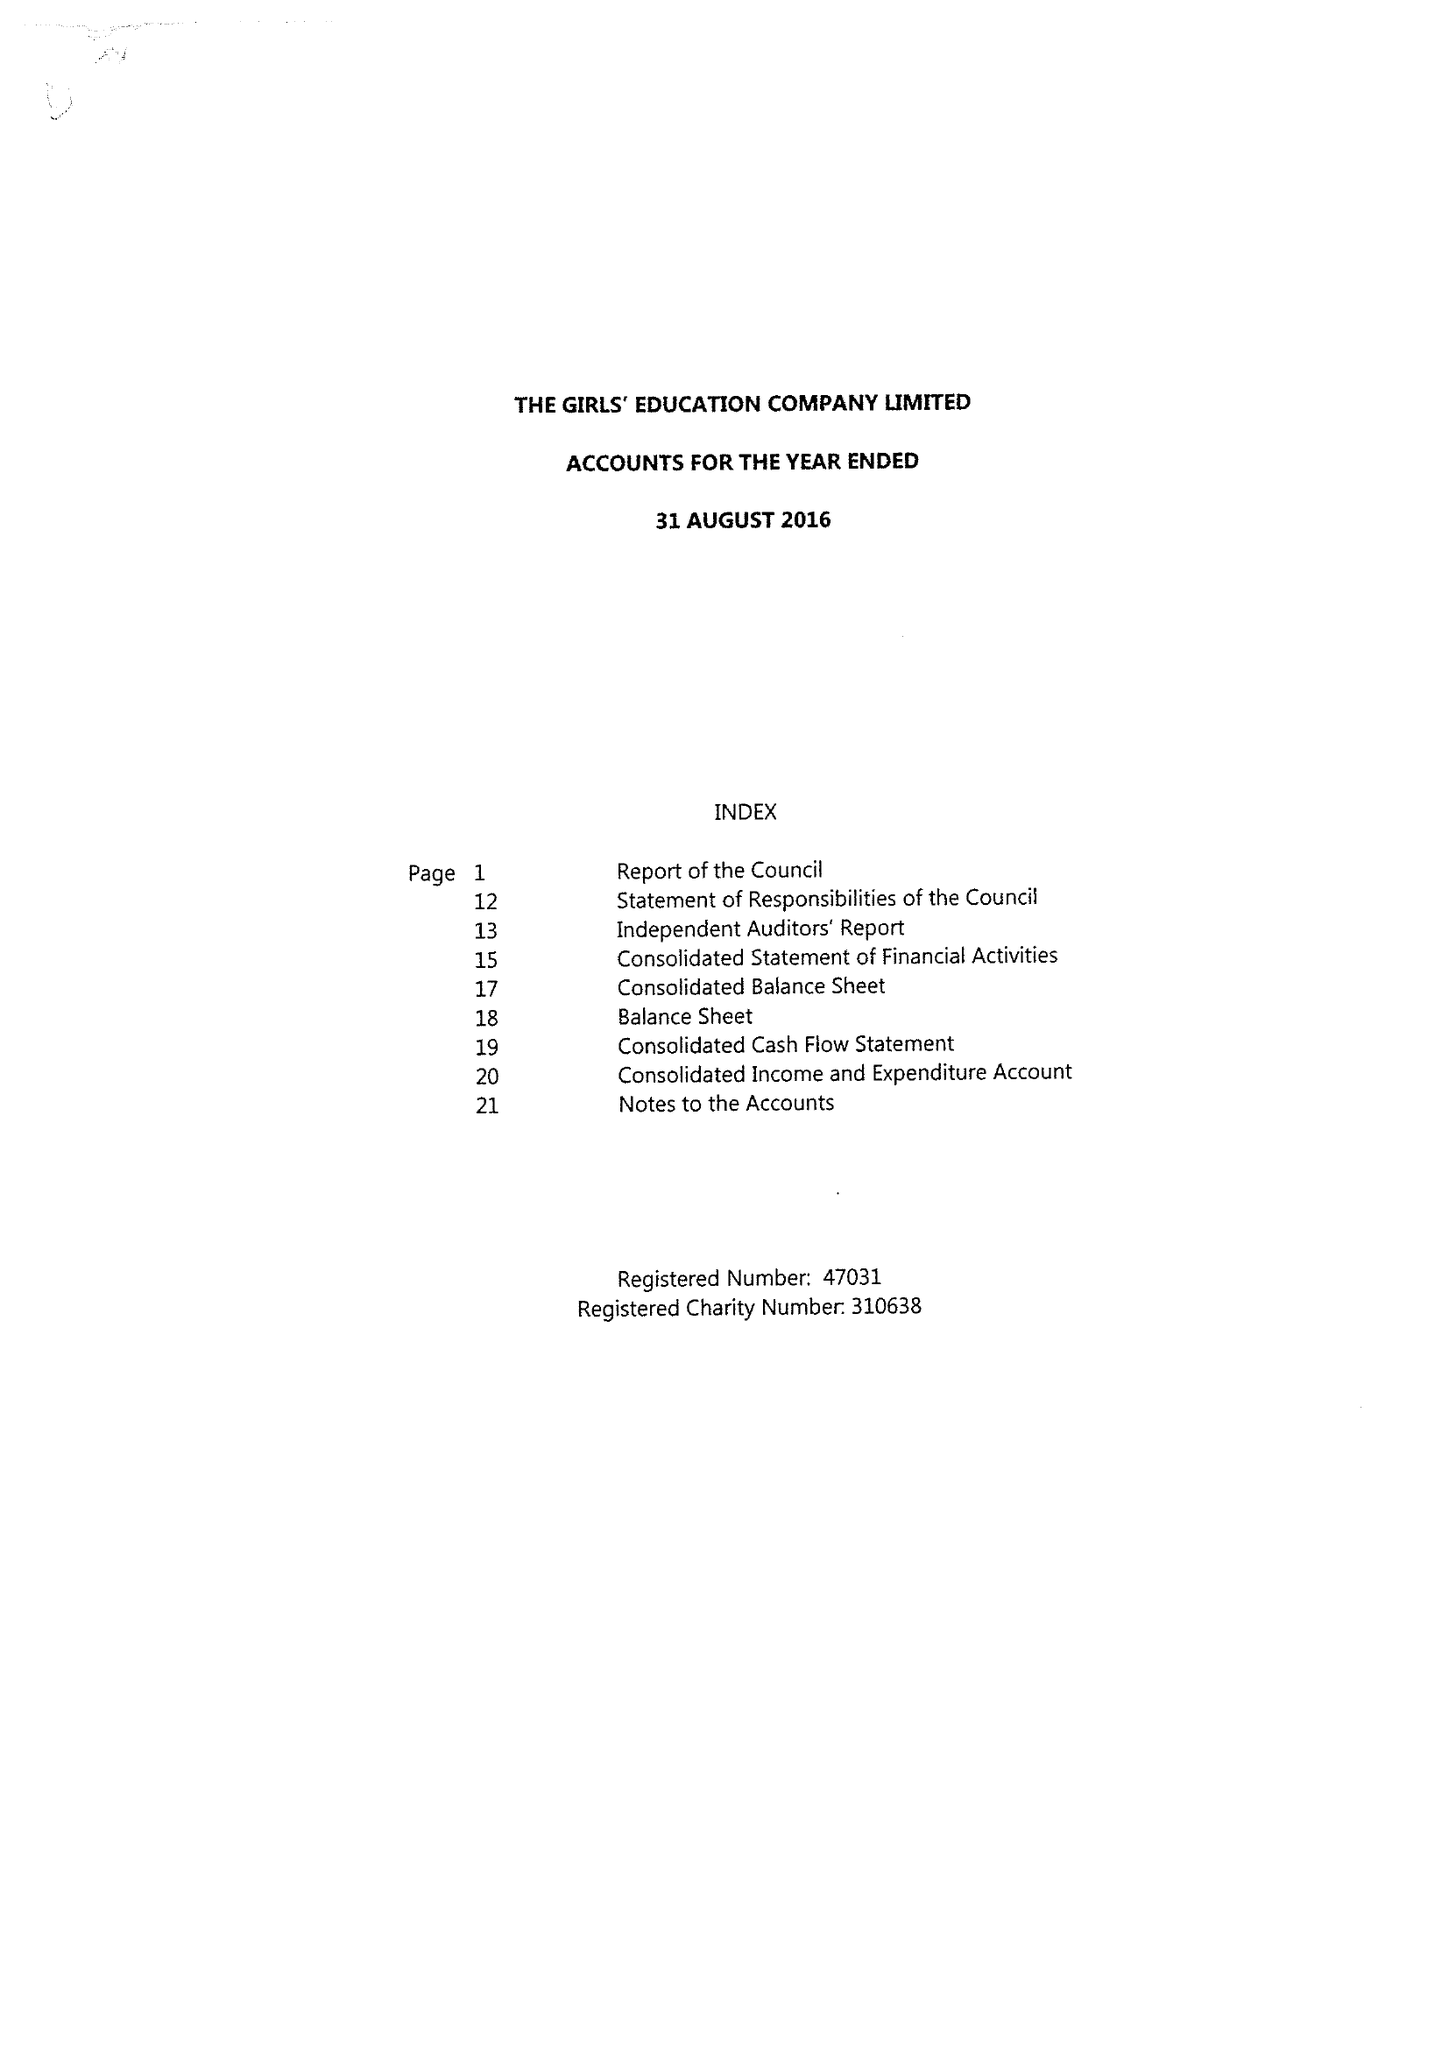What is the value for the address__post_town?
Answer the question using a single word or phrase. HIGH WYCOMBE 